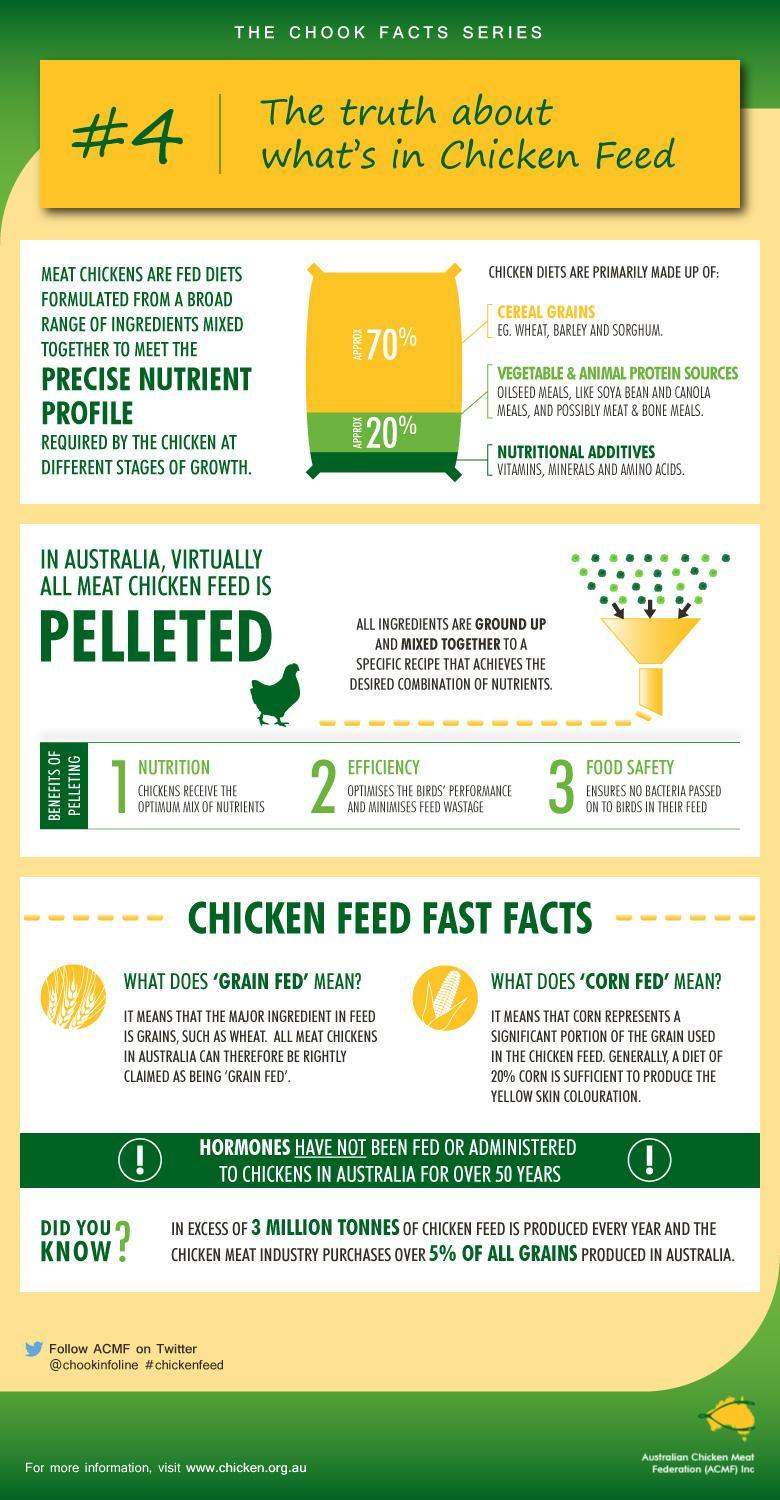What are the examples of cereals used in chicken feed?
Answer the question with a short phrase. wheat, barley and sorghum What is the approximate of percentage of cereal grains in chicken diets? 70% Which additives are included in the chicken feed? vitamins, minerals and amino acids How does pelleting affect nutrition? chickens receive the optimum mix of nutrients What is 20% of the contents of chicken diets made up of? vegetable & animal protein sources 